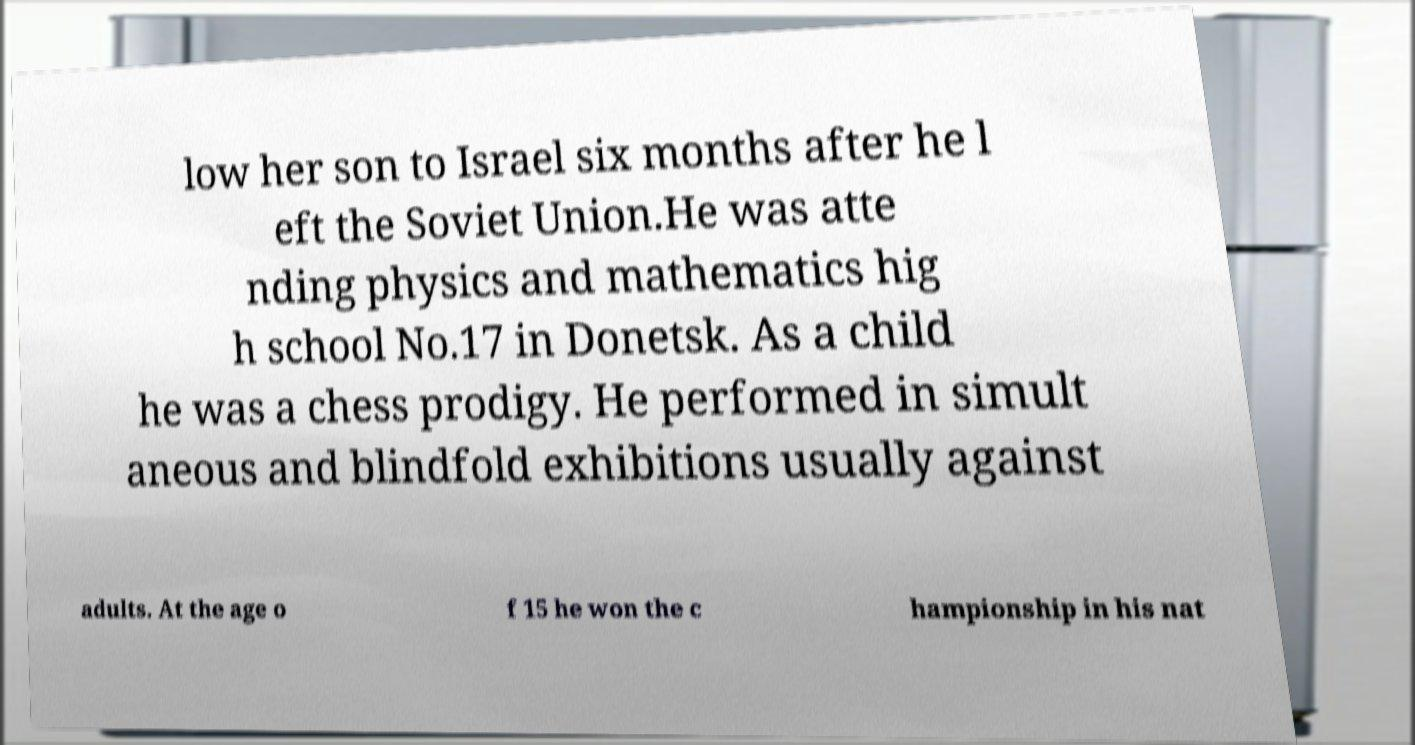Could you assist in decoding the text presented in this image and type it out clearly? low her son to Israel six months after he l eft the Soviet Union.He was atte nding physics and mathematics hig h school No.17 in Donetsk. As a child he was a chess prodigy. He performed in simult aneous and blindfold exhibitions usually against adults. At the age o f 15 he won the c hampionship in his nat 